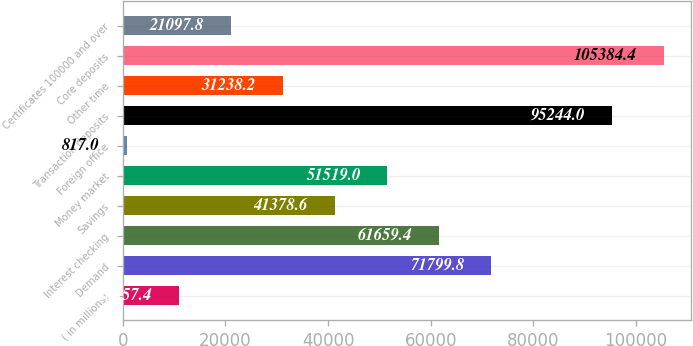Convert chart to OTSL. <chart><loc_0><loc_0><loc_500><loc_500><bar_chart><fcel>( in millions)<fcel>Demand<fcel>Interest checking<fcel>Savings<fcel>Money market<fcel>Foreign office<fcel>Transaction deposits<fcel>Other time<fcel>Core deposits<fcel>Certificates 100000 and over<nl><fcel>10957.4<fcel>71799.8<fcel>61659.4<fcel>41378.6<fcel>51519<fcel>817<fcel>95244<fcel>31238.2<fcel>105384<fcel>21097.8<nl></chart> 